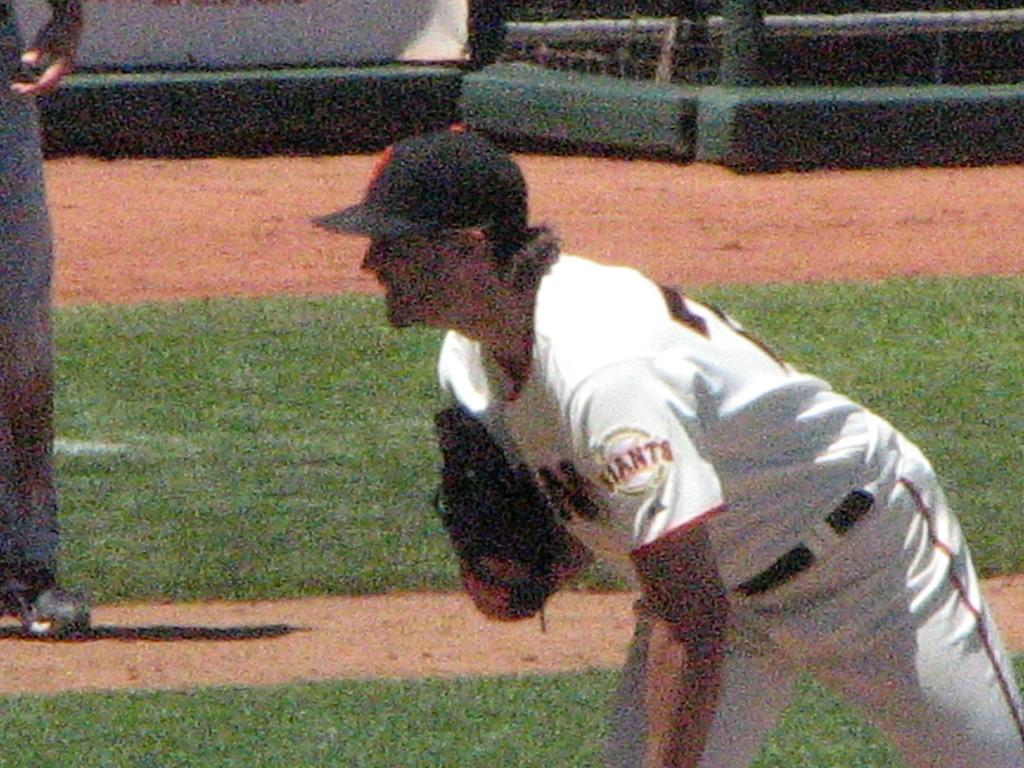<image>
Offer a succinct explanation of the picture presented. the word Giants on the side of a jersey 